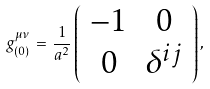<formula> <loc_0><loc_0><loc_500><loc_500>g _ { ( 0 ) } ^ { \mu \nu } \, = \, \frac { 1 } { a ^ { 2 } } \left ( \begin{array} { c c } - 1 & 0 \\ 0 & \delta ^ { i j } \end{array} \right ) ,</formula> 